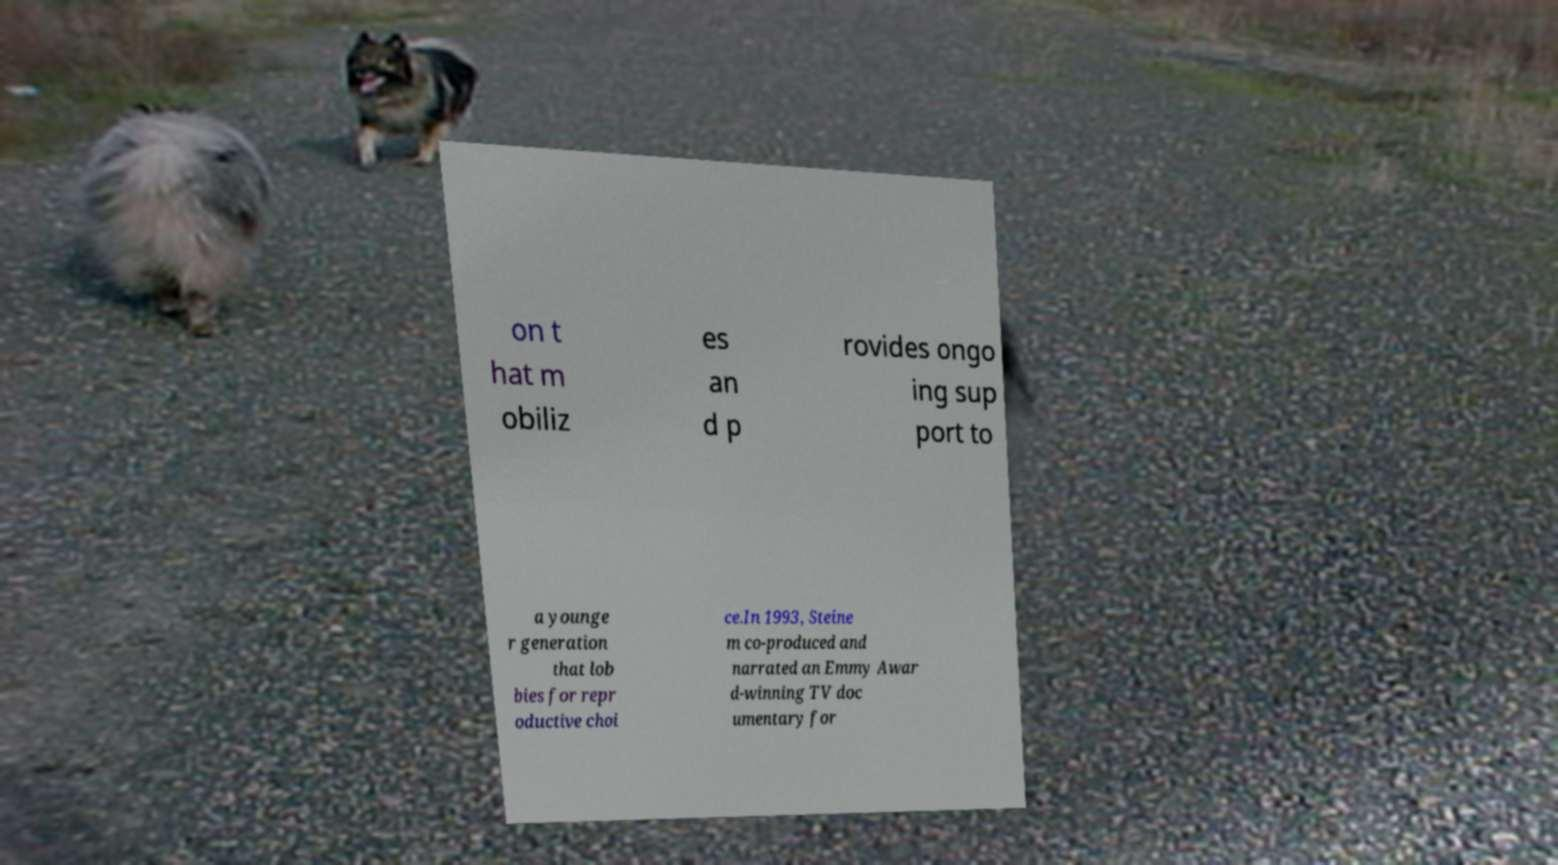Please read and relay the text visible in this image. What does it say? on t hat m obiliz es an d p rovides ongo ing sup port to a younge r generation that lob bies for repr oductive choi ce.In 1993, Steine m co-produced and narrated an Emmy Awar d-winning TV doc umentary for 